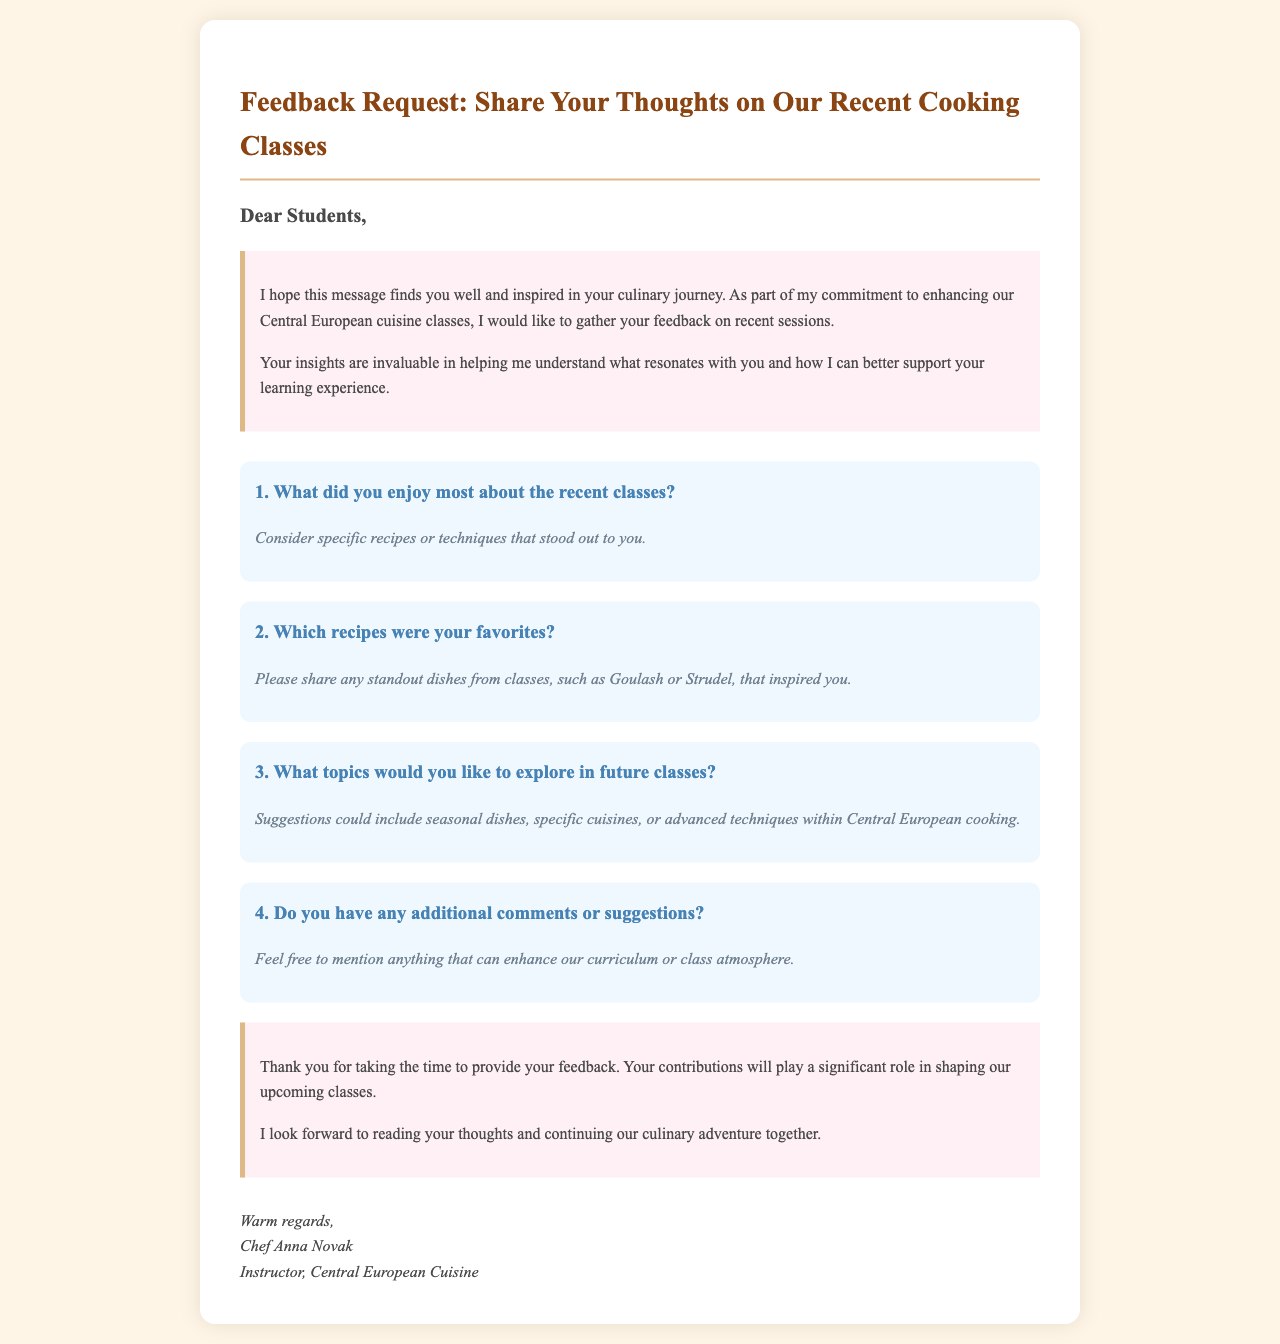What is the title of the letter? The title is located at the top of the document and clearly states the purpose of the message.
Answer: Feedback Request: Share Your Thoughts on Our Recent Cooking Classes Who is the sender of the letter? The sender's name is provided at the end of the letter, including their title and specialty.
Answer: Chef Anna Novak What is the main purpose of the feedback request? The purpose is outlined in the introduction and focuses on gathering insights from students to enhance future classes.
Answer: To gather feedback on recent classes What recipe is mentioned as an example in the second question? The specific recipe is highlighted as an example of a favorite dish that students might have enjoyed in class.
Answer: Goulash How many main questions are included in the document? The number of main questions can be counted from the question section of the document.
Answer: Four What is the closing sentiment expressed in the letter? The conclusion shares a note of gratitude and anticipation for future contributions from students.
Answer: Thank you for taking the time to provide your feedback What style is the font used in the document? The font style is indicated in the body styling section of the document, providing a classic appearance.
Answer: Garamond What thematic cuisine is the instructor specializing in? The thematic cuisine is mentioned several times in the document, emphasizing the cooking focus.
Answer: Central European cuisine 